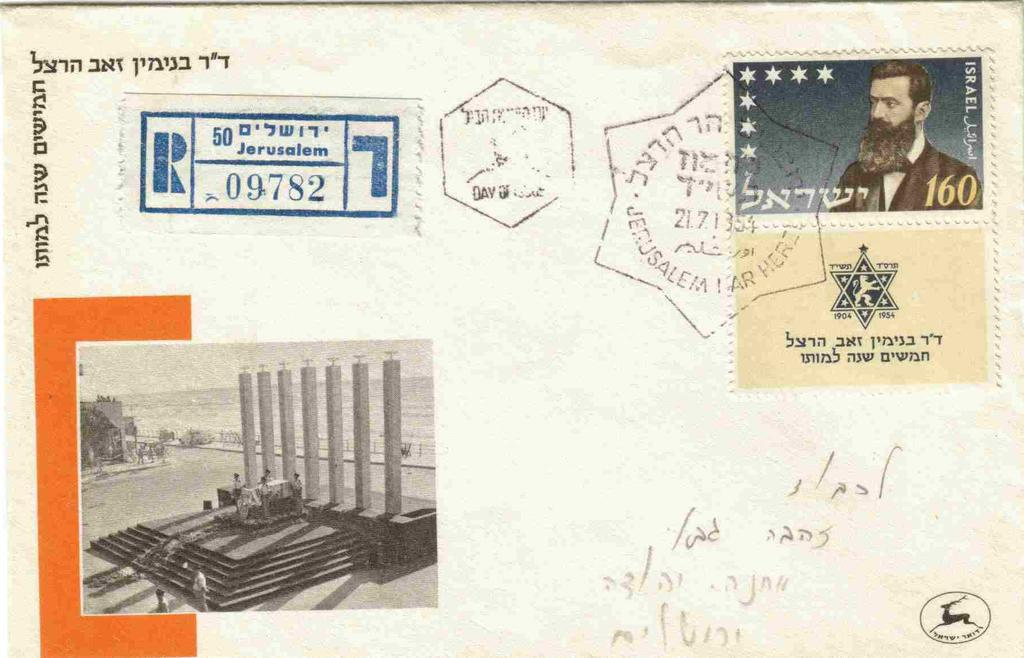<image>
Render a clear and concise summary of the photo. A stamp on a postcard features a bearded man and the number 160. 